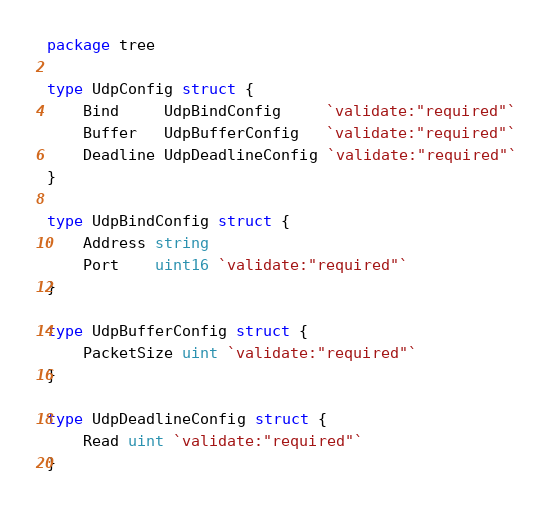Convert code to text. <code><loc_0><loc_0><loc_500><loc_500><_Go_>package tree

type UdpConfig struct {
	Bind     UdpBindConfig     `validate:"required"`
	Buffer   UdpBufferConfig   `validate:"required"`
	Deadline UdpDeadlineConfig `validate:"required"`
}

type UdpBindConfig struct {
	Address string
	Port    uint16 `validate:"required"`
}

type UdpBufferConfig struct {
	PacketSize uint `validate:"required"`
}

type UdpDeadlineConfig struct {
	Read uint `validate:"required"`
}
</code> 